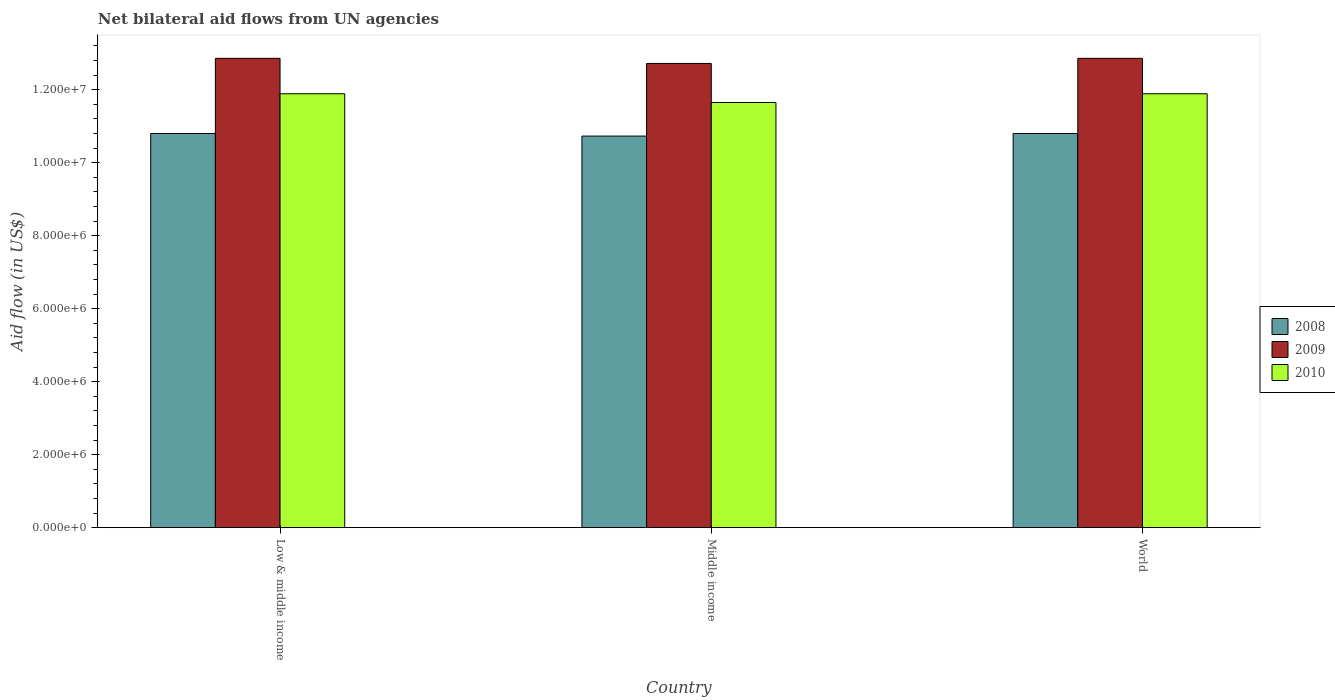How many different coloured bars are there?
Ensure brevity in your answer.  3. Are the number of bars per tick equal to the number of legend labels?
Provide a succinct answer. Yes. Are the number of bars on each tick of the X-axis equal?
Your answer should be very brief. Yes. How many bars are there on the 3rd tick from the right?
Offer a very short reply. 3. What is the net bilateral aid flow in 2010 in World?
Offer a very short reply. 1.19e+07. Across all countries, what is the maximum net bilateral aid flow in 2008?
Ensure brevity in your answer.  1.08e+07. Across all countries, what is the minimum net bilateral aid flow in 2010?
Provide a succinct answer. 1.16e+07. In which country was the net bilateral aid flow in 2009 maximum?
Keep it short and to the point. Low & middle income. In which country was the net bilateral aid flow in 2010 minimum?
Make the answer very short. Middle income. What is the total net bilateral aid flow in 2009 in the graph?
Your answer should be compact. 3.84e+07. What is the difference between the net bilateral aid flow in 2008 in Middle income and the net bilateral aid flow in 2010 in World?
Offer a terse response. -1.16e+06. What is the average net bilateral aid flow in 2009 per country?
Provide a succinct answer. 1.28e+07. What is the difference between the net bilateral aid flow of/in 2009 and net bilateral aid flow of/in 2008 in Low & middle income?
Keep it short and to the point. 2.06e+06. In how many countries, is the net bilateral aid flow in 2010 greater than 2000000 US$?
Your response must be concise. 3. What is the ratio of the net bilateral aid flow in 2008 in Low & middle income to that in World?
Ensure brevity in your answer.  1. Is the net bilateral aid flow in 2009 in Low & middle income less than that in Middle income?
Your answer should be compact. No. What is the difference between the highest and the second highest net bilateral aid flow in 2009?
Ensure brevity in your answer.  1.40e+05. What is the difference between the highest and the lowest net bilateral aid flow in 2008?
Provide a succinct answer. 7.00e+04. Is the sum of the net bilateral aid flow in 2009 in Middle income and World greater than the maximum net bilateral aid flow in 2010 across all countries?
Give a very brief answer. Yes. Are the values on the major ticks of Y-axis written in scientific E-notation?
Your response must be concise. Yes. Does the graph contain any zero values?
Give a very brief answer. No. Does the graph contain grids?
Keep it short and to the point. No. How are the legend labels stacked?
Provide a short and direct response. Vertical. What is the title of the graph?
Your answer should be very brief. Net bilateral aid flows from UN agencies. Does "1990" appear as one of the legend labels in the graph?
Your response must be concise. No. What is the label or title of the X-axis?
Give a very brief answer. Country. What is the label or title of the Y-axis?
Offer a very short reply. Aid flow (in US$). What is the Aid flow (in US$) of 2008 in Low & middle income?
Your answer should be very brief. 1.08e+07. What is the Aid flow (in US$) in 2009 in Low & middle income?
Provide a succinct answer. 1.29e+07. What is the Aid flow (in US$) of 2010 in Low & middle income?
Ensure brevity in your answer.  1.19e+07. What is the Aid flow (in US$) of 2008 in Middle income?
Ensure brevity in your answer.  1.07e+07. What is the Aid flow (in US$) of 2009 in Middle income?
Offer a terse response. 1.27e+07. What is the Aid flow (in US$) in 2010 in Middle income?
Offer a terse response. 1.16e+07. What is the Aid flow (in US$) of 2008 in World?
Provide a short and direct response. 1.08e+07. What is the Aid flow (in US$) of 2009 in World?
Provide a short and direct response. 1.29e+07. What is the Aid flow (in US$) of 2010 in World?
Give a very brief answer. 1.19e+07. Across all countries, what is the maximum Aid flow (in US$) in 2008?
Offer a very short reply. 1.08e+07. Across all countries, what is the maximum Aid flow (in US$) in 2009?
Give a very brief answer. 1.29e+07. Across all countries, what is the maximum Aid flow (in US$) of 2010?
Make the answer very short. 1.19e+07. Across all countries, what is the minimum Aid flow (in US$) in 2008?
Your answer should be very brief. 1.07e+07. Across all countries, what is the minimum Aid flow (in US$) of 2009?
Make the answer very short. 1.27e+07. Across all countries, what is the minimum Aid flow (in US$) of 2010?
Provide a succinct answer. 1.16e+07. What is the total Aid flow (in US$) of 2008 in the graph?
Your answer should be very brief. 3.23e+07. What is the total Aid flow (in US$) of 2009 in the graph?
Your response must be concise. 3.84e+07. What is the total Aid flow (in US$) in 2010 in the graph?
Make the answer very short. 3.54e+07. What is the difference between the Aid flow (in US$) in 2008 in Low & middle income and that in World?
Make the answer very short. 0. What is the difference between the Aid flow (in US$) of 2008 in Middle income and that in World?
Offer a very short reply. -7.00e+04. What is the difference between the Aid flow (in US$) of 2009 in Middle income and that in World?
Provide a succinct answer. -1.40e+05. What is the difference between the Aid flow (in US$) in 2008 in Low & middle income and the Aid flow (in US$) in 2009 in Middle income?
Offer a very short reply. -1.92e+06. What is the difference between the Aid flow (in US$) in 2008 in Low & middle income and the Aid flow (in US$) in 2010 in Middle income?
Your answer should be compact. -8.50e+05. What is the difference between the Aid flow (in US$) in 2009 in Low & middle income and the Aid flow (in US$) in 2010 in Middle income?
Provide a succinct answer. 1.21e+06. What is the difference between the Aid flow (in US$) of 2008 in Low & middle income and the Aid flow (in US$) of 2009 in World?
Ensure brevity in your answer.  -2.06e+06. What is the difference between the Aid flow (in US$) in 2008 in Low & middle income and the Aid flow (in US$) in 2010 in World?
Give a very brief answer. -1.09e+06. What is the difference between the Aid flow (in US$) of 2009 in Low & middle income and the Aid flow (in US$) of 2010 in World?
Your answer should be compact. 9.70e+05. What is the difference between the Aid flow (in US$) of 2008 in Middle income and the Aid flow (in US$) of 2009 in World?
Provide a succinct answer. -2.13e+06. What is the difference between the Aid flow (in US$) in 2008 in Middle income and the Aid flow (in US$) in 2010 in World?
Keep it short and to the point. -1.16e+06. What is the difference between the Aid flow (in US$) of 2009 in Middle income and the Aid flow (in US$) of 2010 in World?
Provide a short and direct response. 8.30e+05. What is the average Aid flow (in US$) in 2008 per country?
Ensure brevity in your answer.  1.08e+07. What is the average Aid flow (in US$) in 2009 per country?
Your answer should be compact. 1.28e+07. What is the average Aid flow (in US$) in 2010 per country?
Offer a terse response. 1.18e+07. What is the difference between the Aid flow (in US$) of 2008 and Aid flow (in US$) of 2009 in Low & middle income?
Offer a very short reply. -2.06e+06. What is the difference between the Aid flow (in US$) of 2008 and Aid flow (in US$) of 2010 in Low & middle income?
Provide a short and direct response. -1.09e+06. What is the difference between the Aid flow (in US$) of 2009 and Aid flow (in US$) of 2010 in Low & middle income?
Provide a succinct answer. 9.70e+05. What is the difference between the Aid flow (in US$) in 2008 and Aid flow (in US$) in 2009 in Middle income?
Your response must be concise. -1.99e+06. What is the difference between the Aid flow (in US$) of 2008 and Aid flow (in US$) of 2010 in Middle income?
Your answer should be very brief. -9.20e+05. What is the difference between the Aid flow (in US$) in 2009 and Aid flow (in US$) in 2010 in Middle income?
Give a very brief answer. 1.07e+06. What is the difference between the Aid flow (in US$) of 2008 and Aid flow (in US$) of 2009 in World?
Keep it short and to the point. -2.06e+06. What is the difference between the Aid flow (in US$) in 2008 and Aid flow (in US$) in 2010 in World?
Make the answer very short. -1.09e+06. What is the difference between the Aid flow (in US$) in 2009 and Aid flow (in US$) in 2010 in World?
Offer a terse response. 9.70e+05. What is the ratio of the Aid flow (in US$) of 2008 in Low & middle income to that in Middle income?
Provide a short and direct response. 1.01. What is the ratio of the Aid flow (in US$) in 2010 in Low & middle income to that in Middle income?
Your answer should be very brief. 1.02. What is the ratio of the Aid flow (in US$) in 2008 in Low & middle income to that in World?
Your answer should be compact. 1. What is the ratio of the Aid flow (in US$) in 2009 in Low & middle income to that in World?
Give a very brief answer. 1. What is the ratio of the Aid flow (in US$) of 2010 in Low & middle income to that in World?
Your answer should be very brief. 1. What is the ratio of the Aid flow (in US$) of 2009 in Middle income to that in World?
Make the answer very short. 0.99. What is the ratio of the Aid flow (in US$) of 2010 in Middle income to that in World?
Your answer should be compact. 0.98. What is the difference between the highest and the second highest Aid flow (in US$) in 2008?
Offer a very short reply. 0. What is the difference between the highest and the second highest Aid flow (in US$) in 2009?
Make the answer very short. 0. 